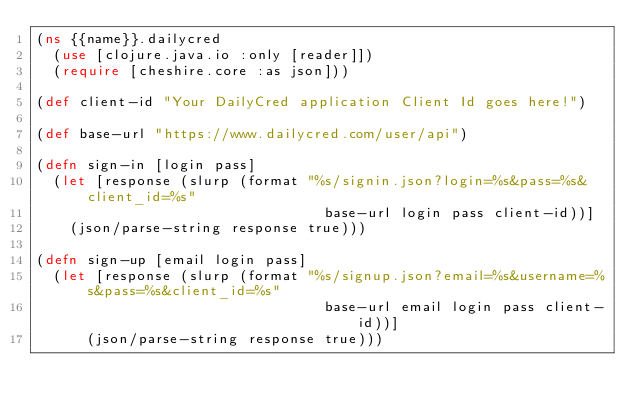Convert code to text. <code><loc_0><loc_0><loc_500><loc_500><_Clojure_>(ns {{name}}.dailycred
  (use [clojure.java.io :only [reader]])
  (require [cheshire.core :as json]))

(def client-id "Your DailyCred application Client Id goes here!")

(def base-url "https://www.dailycred.com/user/api")

(defn sign-in [login pass] 
  (let [response (slurp (format "%s/signin.json?login=%s&pass=%s&client_id=%s"
                                  base-url login pass client-id))]
    (json/parse-string response true)))

(defn sign-up [email login pass] 
  (let [response (slurp (format "%s/signup.json?email=%s&username=%s&pass=%s&client_id=%s"
                                  base-url email login pass client-id))]
      (json/parse-string response true)))</code> 